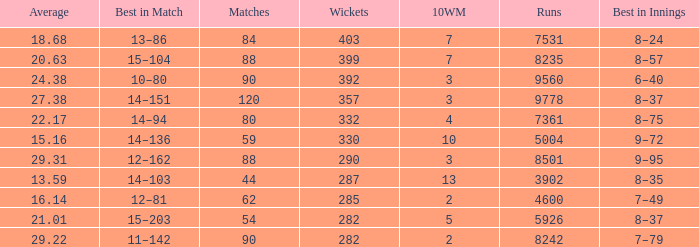What is the total number of wickets that have runs under 4600 and matches under 44? None. 